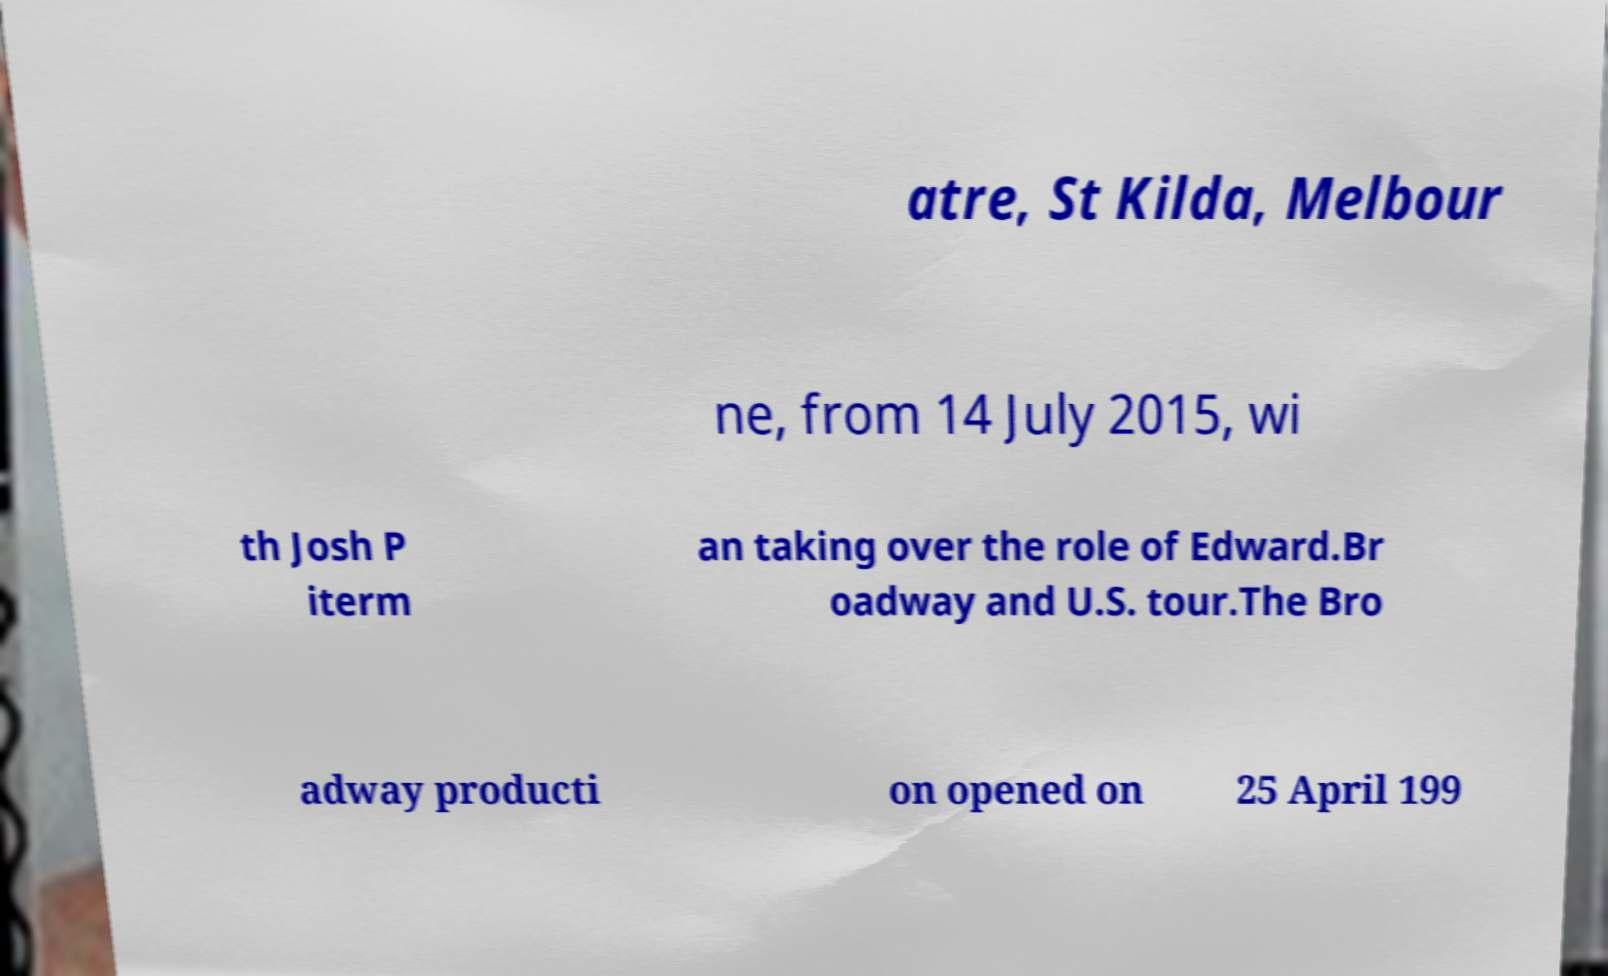Could you assist in decoding the text presented in this image and type it out clearly? atre, St Kilda, Melbour ne, from 14 July 2015, wi th Josh P iterm an taking over the role of Edward.Br oadway and U.S. tour.The Bro adway producti on opened on 25 April 199 